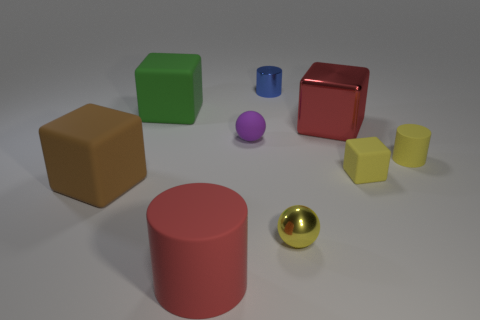What material is the yellow sphere?
Offer a terse response. Metal. Do the tiny thing that is to the left of the tiny blue cylinder and the tiny yellow sphere have the same material?
Offer a terse response. No. There is a brown thing; is it the same size as the matte cylinder left of the small yellow rubber cylinder?
Your answer should be compact. Yes. There is a ball right of the purple rubber thing; what is its material?
Offer a very short reply. Metal. Are there the same number of tiny purple things that are on the right side of the blue thing and tiny yellow rubber objects?
Ensure brevity in your answer.  No. Do the brown block and the red shiny cube have the same size?
Your answer should be very brief. Yes. Is there a big red cube that is behind the large object that is to the right of the rubber object in front of the brown object?
Make the answer very short. No. There is another tiny object that is the same shape as the blue metallic thing; what material is it?
Give a very brief answer. Rubber. There is a sphere on the left side of the yellow shiny thing; what number of matte cubes are behind it?
Make the answer very short. 1. There is a shiny cube in front of the green matte object that is behind the large red thing behind the big brown rubber thing; how big is it?
Your response must be concise. Large. 